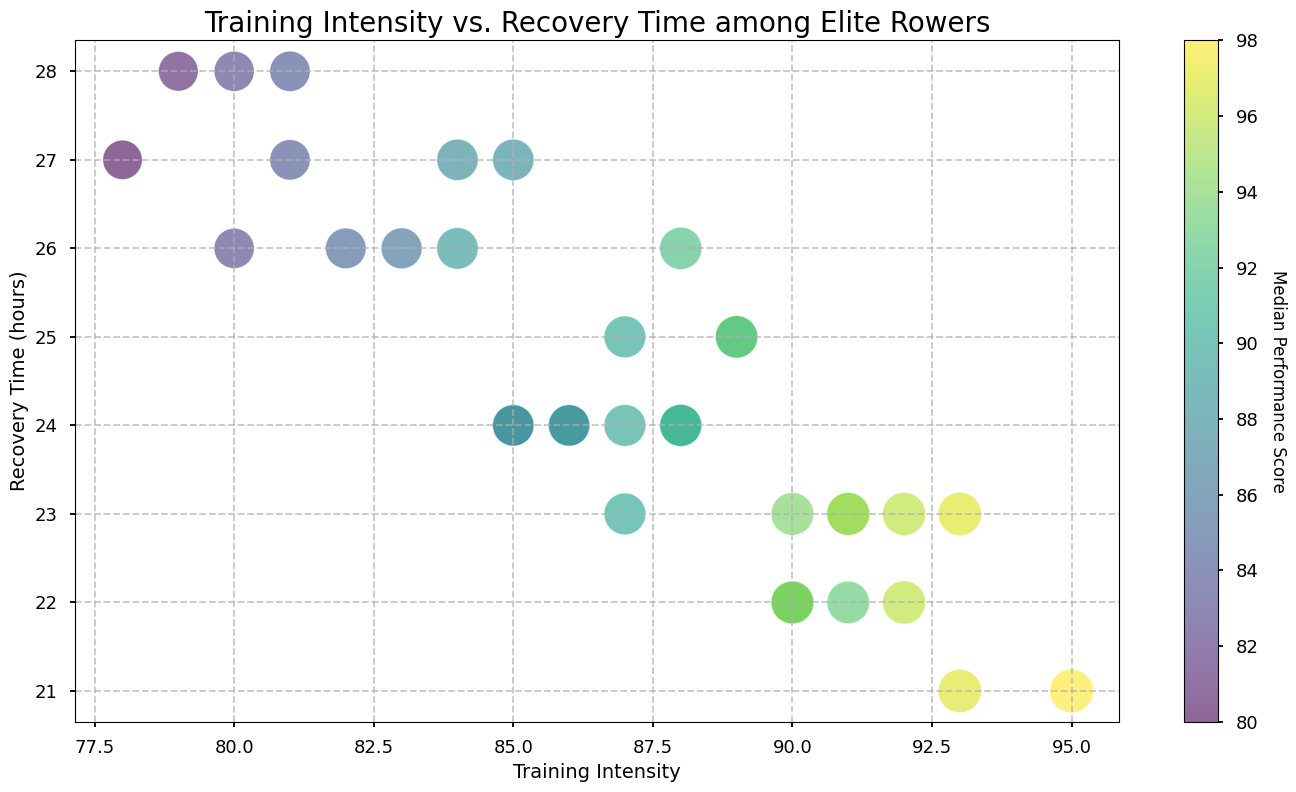What training intensity range shows the highest median performance scores? By looking at the color map and the size of the bubbles, the highest median performance scores appear to be with training intensities in the range of around 90 to 95. This is because the largest and darkest bubbles are within this range.
Answer: Around 90 to 95 Which rower has the highest training intensity and what is their median performance score? The point with the highest training intensity on the x-axis is at 95. According to the figure, the median performance score for this rower is 98.
Answer: 98 Is there any visible correlation between training intensity and recovery time among the best-performing rowers? Observing the bubbles with the darkest colors (highest median performance scores), they seem to cluster around a training intensity of 90 to 93 and recovery time of 22 to 23 hours, suggesting there may be a slight negative correlation between training intensity and recovery time for the best performers.
Answer: Slight negative correlation How does the recovery time of rowers with a training intensity of 90 compare to those with 80? By examining the y-axis positions for these training intensities, rowers with a training intensity of 90 generally have lower recovery times (around 22–23 hours) compared to those with a training intensity of 80 (around 26-28 hours).
Answer: Lower recovery time for 90 What is the average median performance score for training intensities between 85 and 90? The relevant points are at Training Intensity 85, 86, 87, 88, 89, and 90. Median Performance Scores here are 88, 87, 90, 91, 92, and 94 respectively. Adding these gives 542, dividing by 6 gives an approximate average of 90.33.
Answer: 90.33 Which training intensity has the most consistent recovery time, and what is the range of recovery times for that intensity? The figure's clusters show that the training intensity of 90 has recovery times primarily clustered around 22 to 23 hours. The range is from 22 to 23 hours.
Answer: 90, range 22-23 hours How does the median performance score for rowers with a training intensity of 92 differ from those with a training intensity of 93? According to the size and color of the bubbles, for training intensity 92, the scores are 96. For training intensity 93, scores are 97. The difference is 1 point.
Answer: 1 point What visual cue indicates the best performing rowers? The best performing rowers are indicated by the darkest and largest bubbles on the scatter plot.
Answer: Dark and large bubbles 